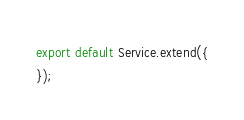Convert code to text. <code><loc_0><loc_0><loc_500><loc_500><_JavaScript_>
export default Service.extend({
});
</code> 